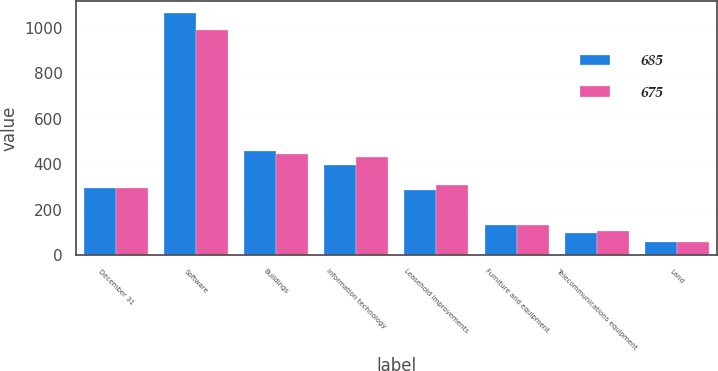Convert chart. <chart><loc_0><loc_0><loc_500><loc_500><stacked_bar_chart><ecel><fcel>December 31<fcel>Software<fcel>Buildings<fcel>Information technology<fcel>Leasehold improvements<fcel>Furniture and equipment<fcel>Telecommunications equipment<fcel>Land<nl><fcel>685<fcel>297<fcel>1067<fcel>456<fcel>398<fcel>287<fcel>133<fcel>95<fcel>59<nl><fcel>675<fcel>297<fcel>993<fcel>446<fcel>430<fcel>307<fcel>131<fcel>104<fcel>59<nl></chart> 